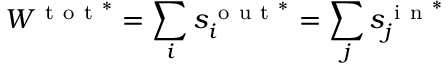<formula> <loc_0><loc_0><loc_500><loc_500>W ^ { t o t ^ { * } } = \sum _ { i } s _ { i } ^ { o u t ^ { * } } = \sum _ { j } s _ { j } ^ { i n ^ { * } }</formula> 